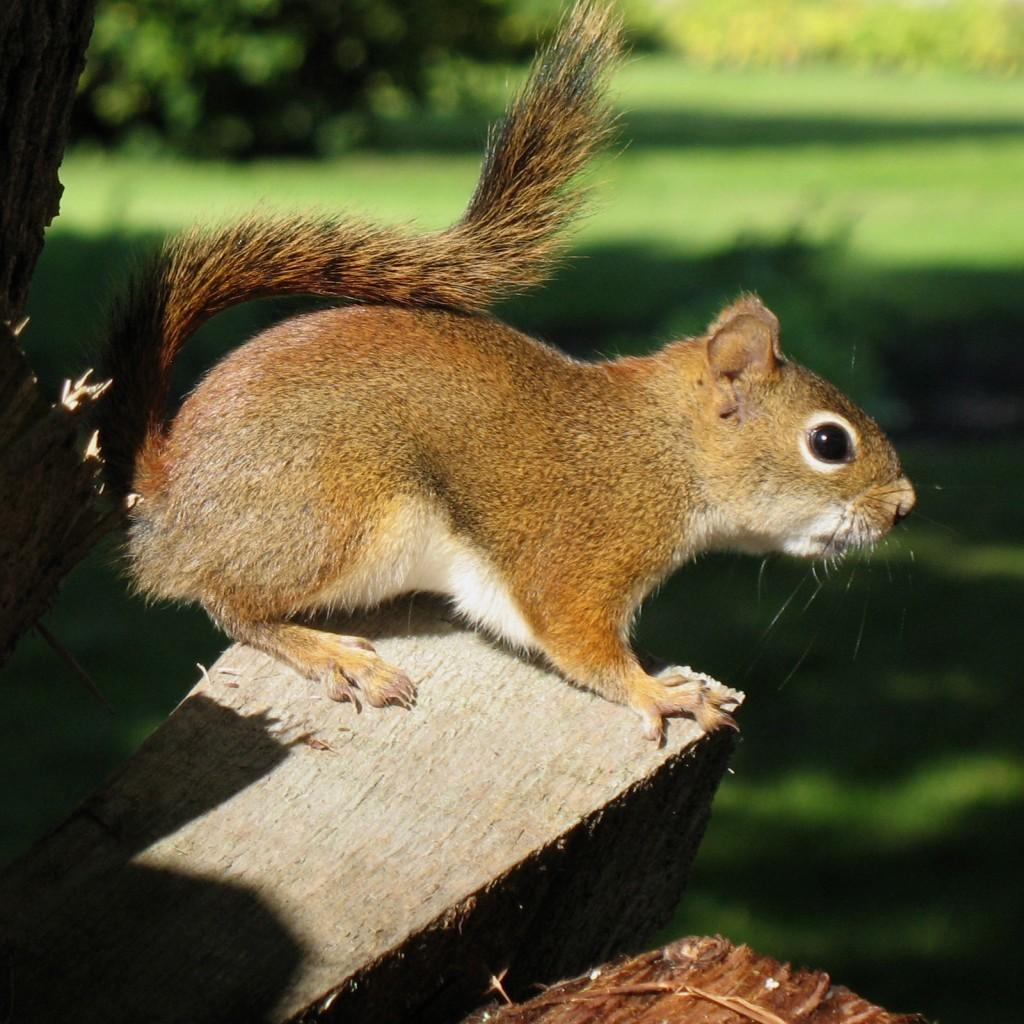What animal can be seen in the image? There is a squirrel in the image. Where is the squirrel located? The squirrel is on a branch. What can be seen in the background of the image? The background includes the ground. What type of spark can be seen coming from the squirrel's tail in the image? There is no spark present in the image; the squirrel's tail is not shown emitting any sparks. 